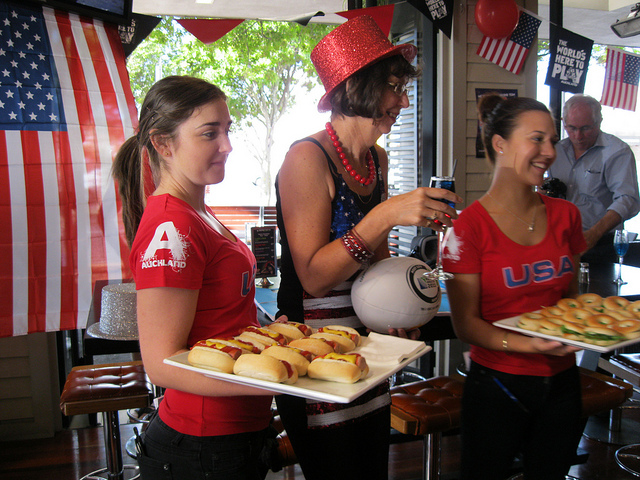<image>What color is the statue's dress jacket? There is no statue in the image. However, if there was, the jacket could be red or red white blue. What color is the statue's dress jacket? I don't know what color the statue's dress jacket is. It can be red or none. 